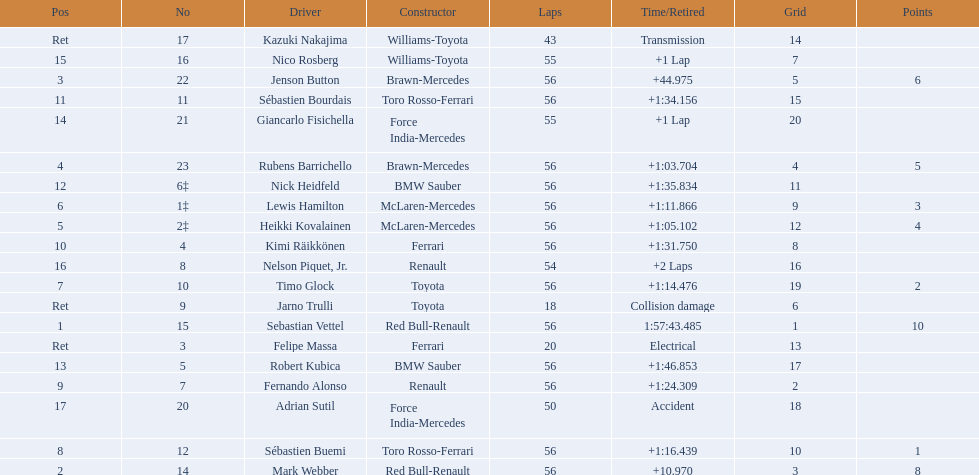Who were all of the drivers in the 2009 chinese grand prix? Sebastian Vettel, Mark Webber, Jenson Button, Rubens Barrichello, Heikki Kovalainen, Lewis Hamilton, Timo Glock, Sébastien Buemi, Fernando Alonso, Kimi Räikkönen, Sébastien Bourdais, Nick Heidfeld, Robert Kubica, Giancarlo Fisichella, Nico Rosberg, Nelson Piquet, Jr., Adrian Sutil, Kazuki Nakajima, Felipe Massa, Jarno Trulli. And what were their finishing times? 1:57:43.485, +10.970, +44.975, +1:03.704, +1:05.102, +1:11.866, +1:14.476, +1:16.439, +1:24.309, +1:31.750, +1:34.156, +1:35.834, +1:46.853, +1 Lap, +1 Lap, +2 Laps, Accident, Transmission, Electrical, Collision damage. Which player faced collision damage and retired from the race? Jarno Trulli. 